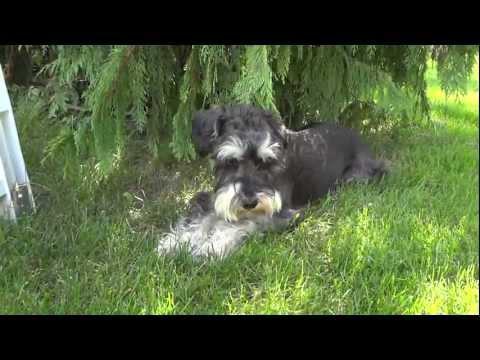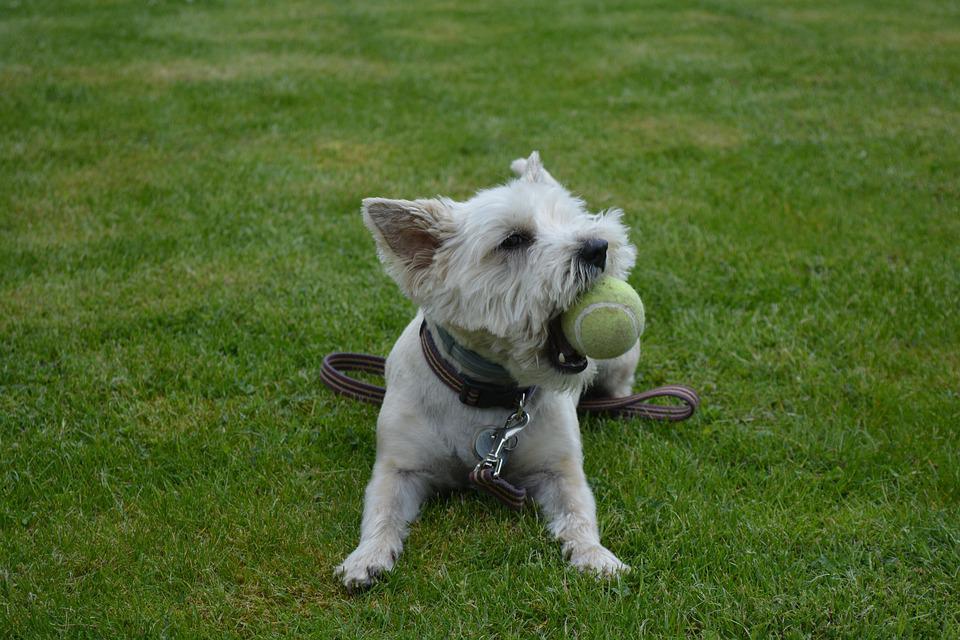The first image is the image on the left, the second image is the image on the right. Examine the images to the left and right. Is the description "There is exactly one dog holding a toy in its mouth." accurate? Answer yes or no. Yes. 